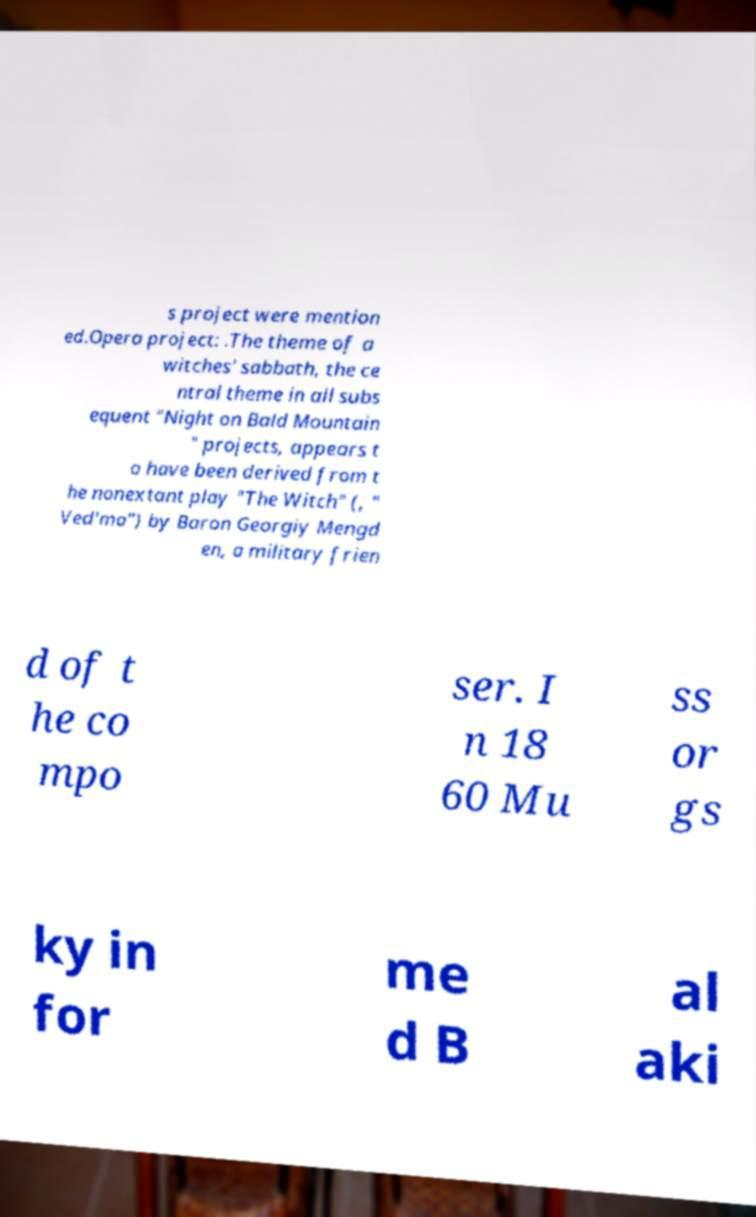There's text embedded in this image that I need extracted. Can you transcribe it verbatim? s project were mention ed.Opera project: .The theme of a witches' sabbath, the ce ntral theme in all subs equent "Night on Bald Mountain " projects, appears t o have been derived from t he nonextant play "The Witch" (, " Ved′ma") by Baron Georgiy Mengd en, a military frien d of t he co mpo ser. I n 18 60 Mu ss or gs ky in for me d B al aki 